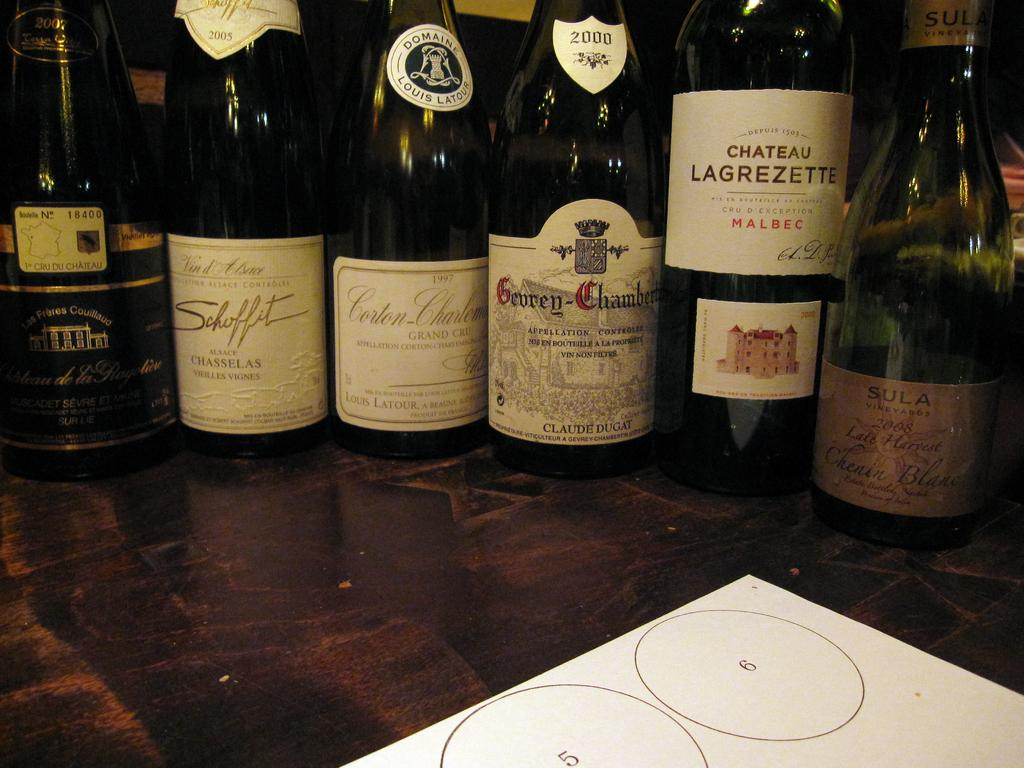<image>
Describe the image concisely. several bottles of wine, one of which has Chateau Lagrezette on the label 